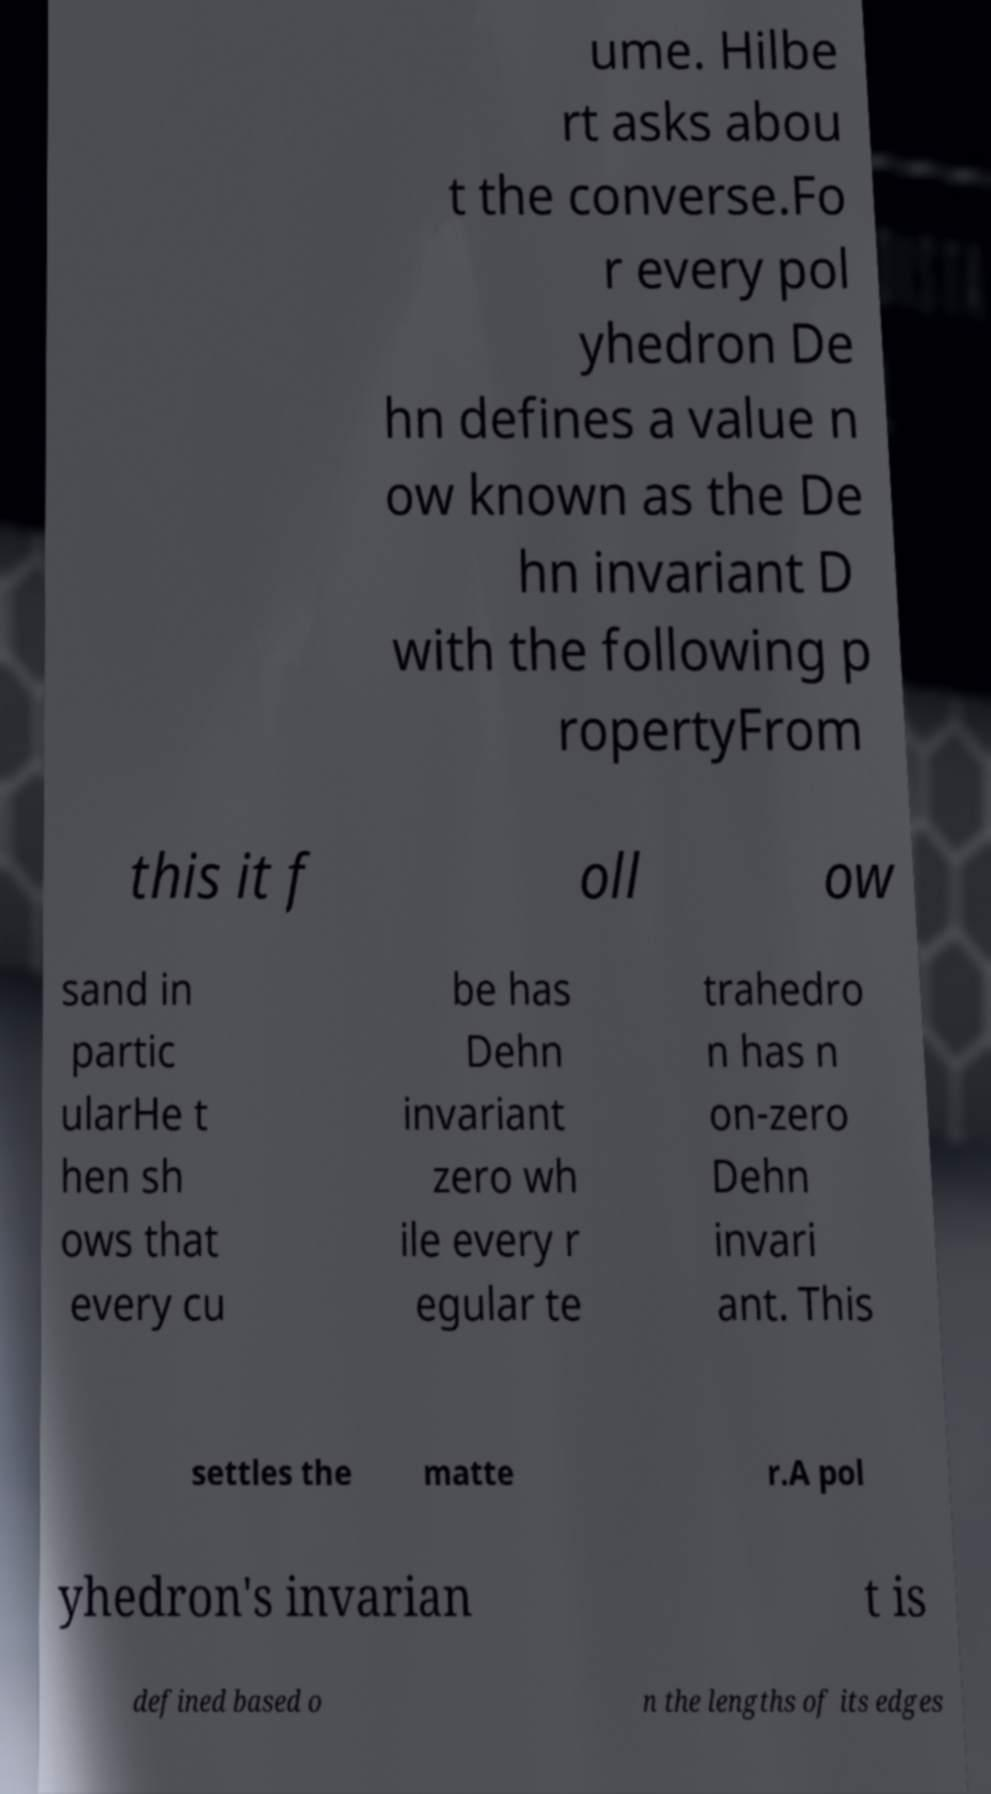Can you accurately transcribe the text from the provided image for me? ume. Hilbe rt asks abou t the converse.Fo r every pol yhedron De hn defines a value n ow known as the De hn invariant D with the following p ropertyFrom this it f oll ow sand in partic ularHe t hen sh ows that every cu be has Dehn invariant zero wh ile every r egular te trahedro n has n on-zero Dehn invari ant. This settles the matte r.A pol yhedron's invarian t is defined based o n the lengths of its edges 